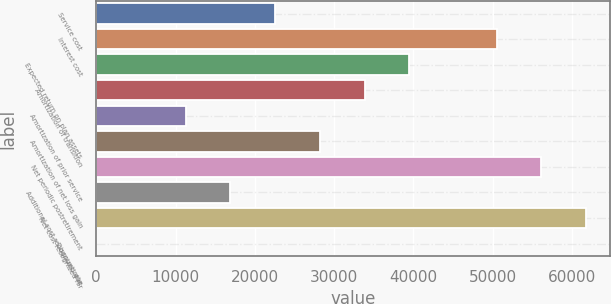<chart> <loc_0><loc_0><loc_500><loc_500><bar_chart><fcel>Service cost<fcel>Interest cost<fcel>Expected return on plan assets<fcel>Amortization of transition<fcel>Amortization of prior service<fcel>Amortization of net loss gain<fcel>Net periodic postretirement<fcel>Additional cost recognized due<fcel>Net cost recognized for<fcel>Discount rate<nl><fcel>22553.6<fcel>50475<fcel>39464.3<fcel>33827.4<fcel>11279.8<fcel>28190.5<fcel>56111.9<fcel>16916.7<fcel>61748.8<fcel>6<nl></chart> 